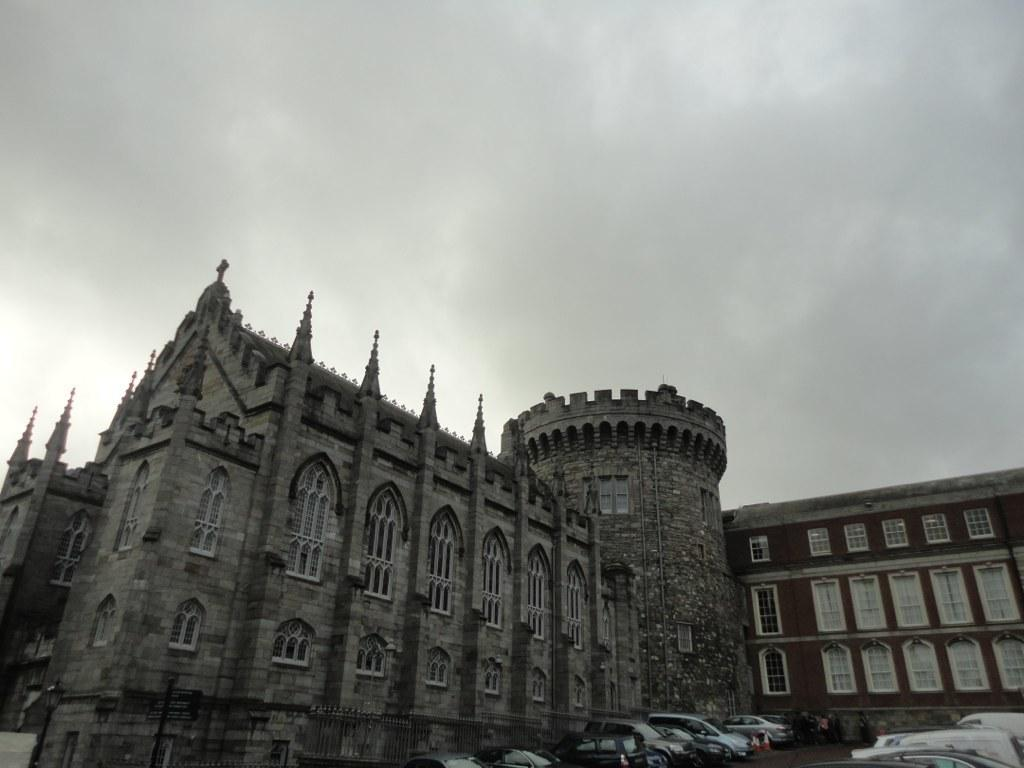What is the main structure in the picture? There is a building in the picture. What feature can be seen on the building? The building has windows. What type of vehicles are parked in the picture? There are cars parked in the picture. What is visible at the top of the picture? The sky is visible at the top of the picture. Can you tell me how many cubs are playing with a balance and a book in the image? There are no cubs, balance, or book present in the image. 